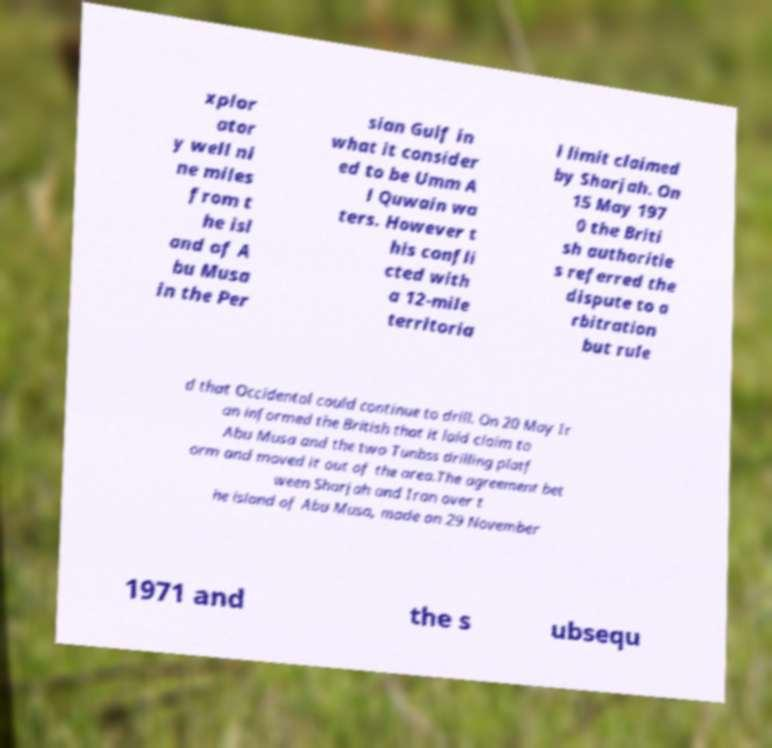There's text embedded in this image that I need extracted. Can you transcribe it verbatim? xplor ator y well ni ne miles from t he isl and of A bu Musa in the Per sian Gulf in what it consider ed to be Umm A l Quwain wa ters. However t his confli cted with a 12-mile territoria l limit claimed by Sharjah. On 15 May 197 0 the Briti sh authoritie s referred the dispute to a rbitration but rule d that Occidental could continue to drill. On 20 May Ir an informed the British that it laid claim to Abu Musa and the two Tunbss drilling platf orm and moved it out of the area.The agreement bet ween Sharjah and Iran over t he island of Abu Musa, made on 29 November 1971 and the s ubsequ 